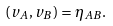Convert formula to latex. <formula><loc_0><loc_0><loc_500><loc_500>\left ( v _ { A } , v _ { B } \right ) = \eta _ { A B } .</formula> 